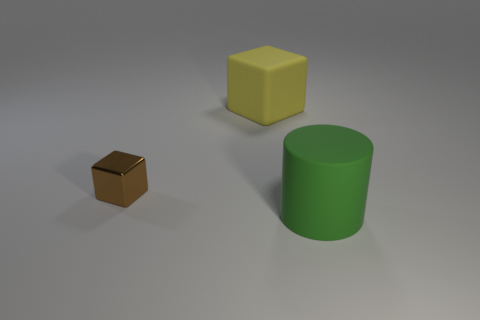Add 2 big red blocks. How many objects exist? 5 Subtract all cubes. How many objects are left? 1 Add 1 small brown things. How many small brown things are left? 2 Add 1 small yellow cylinders. How many small yellow cylinders exist? 1 Subtract 0 yellow cylinders. How many objects are left? 3 Subtract all small brown metal balls. Subtract all big objects. How many objects are left? 1 